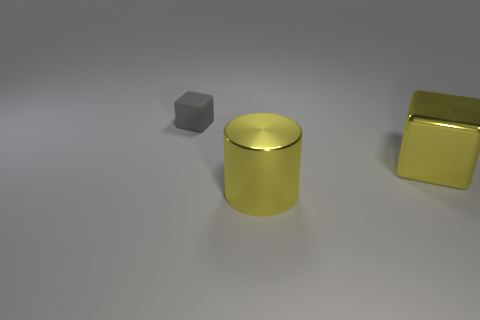The metallic thing that is the same color as the big cylinder is what shape?
Ensure brevity in your answer.  Cube. There is a large cylinder that is the same color as the big shiny cube; what is its material?
Make the answer very short. Metal. Do the cube to the right of the rubber block and the large object in front of the big block have the same color?
Your answer should be very brief. Yes. The big yellow shiny thing to the left of the big shiny thing that is behind the big yellow shiny cylinder is what shape?
Provide a succinct answer. Cylinder. There is a yellow metal cylinder; are there any large yellow shiny things on the right side of it?
Offer a very short reply. Yes. The block that is the same size as the yellow metal cylinder is what color?
Make the answer very short. Yellow. What number of large cubes have the same material as the cylinder?
Offer a terse response. 1. How many other things are the same size as the gray object?
Offer a terse response. 0. Is there a yellow metallic cube that has the same size as the gray rubber thing?
Your answer should be compact. No. Do the block that is in front of the gray rubber cube and the metallic cylinder have the same color?
Make the answer very short. Yes. 